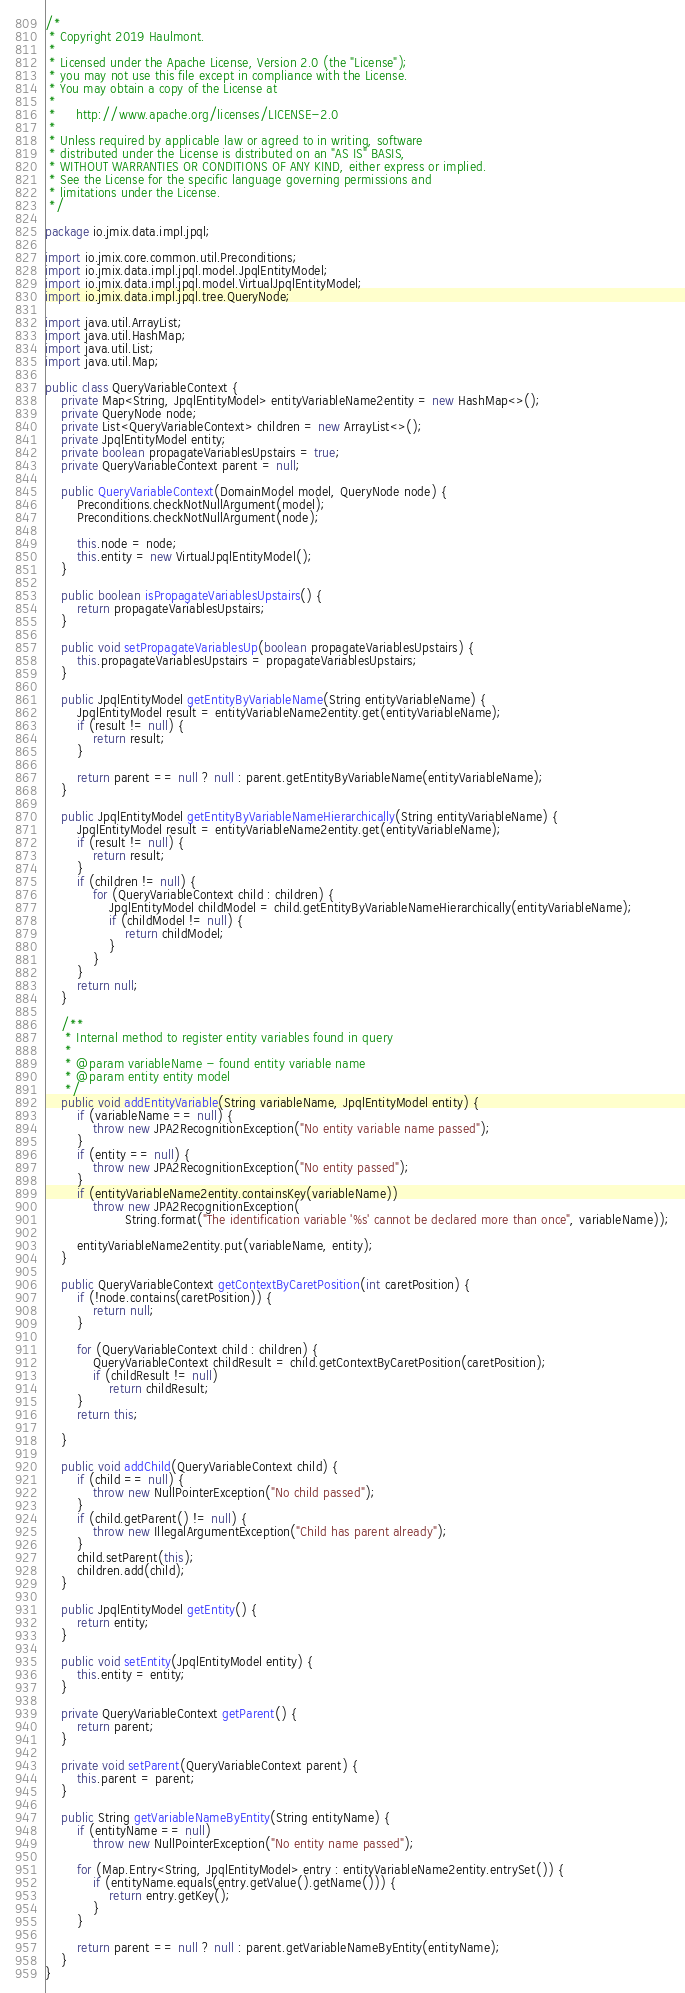Convert code to text. <code><loc_0><loc_0><loc_500><loc_500><_Java_>/*
 * Copyright 2019 Haulmont.
 *
 * Licensed under the Apache License, Version 2.0 (the "License");
 * you may not use this file except in compliance with the License.
 * You may obtain a copy of the License at
 *
 *     http://www.apache.org/licenses/LICENSE-2.0
 *
 * Unless required by applicable law or agreed to in writing, software
 * distributed under the License is distributed on an "AS IS" BASIS,
 * WITHOUT WARRANTIES OR CONDITIONS OF ANY KIND, either express or implied.
 * See the License for the specific language governing permissions and
 * limitations under the License.
 */

package io.jmix.data.impl.jpql;

import io.jmix.core.common.util.Preconditions;
import io.jmix.data.impl.jpql.model.JpqlEntityModel;
import io.jmix.data.impl.jpql.model.VirtualJpqlEntityModel;
import io.jmix.data.impl.jpql.tree.QueryNode;

import java.util.ArrayList;
import java.util.HashMap;
import java.util.List;
import java.util.Map;

public class QueryVariableContext {
    private Map<String, JpqlEntityModel> entityVariableName2entity = new HashMap<>();
    private QueryNode node;
    private List<QueryVariableContext> children = new ArrayList<>();
    private JpqlEntityModel entity;
    private boolean propagateVariablesUpstairs = true;
    private QueryVariableContext parent = null;

    public QueryVariableContext(DomainModel model, QueryNode node) {
        Preconditions.checkNotNullArgument(model);
        Preconditions.checkNotNullArgument(node);

        this.node = node;
        this.entity = new VirtualJpqlEntityModel();
    }

    public boolean isPropagateVariablesUpstairs() {
        return propagateVariablesUpstairs;
    }

    public void setPropagateVariablesUp(boolean propagateVariablesUpstairs) {
        this.propagateVariablesUpstairs = propagateVariablesUpstairs;
    }

    public JpqlEntityModel getEntityByVariableName(String entityVariableName) {
        JpqlEntityModel result = entityVariableName2entity.get(entityVariableName);
        if (result != null) {
            return result;
        }

        return parent == null ? null : parent.getEntityByVariableName(entityVariableName);
    }

    public JpqlEntityModel getEntityByVariableNameHierarchically(String entityVariableName) {
        JpqlEntityModel result = entityVariableName2entity.get(entityVariableName);
        if (result != null) {
            return result;
        }
        if (children != null) {
            for (QueryVariableContext child : children) {
                JpqlEntityModel childModel = child.getEntityByVariableNameHierarchically(entityVariableName);
                if (childModel != null) {
                    return childModel;
                }
            }
        }
        return null;
    }

    /**
     * Internal method to register entity variables found in query
     *
     * @param variableName - found entity variable name
     * @param entity entity model
     */
    public void addEntityVariable(String variableName, JpqlEntityModel entity) {
        if (variableName == null) {
            throw new JPA2RecognitionException("No entity variable name passed");
        }
        if (entity == null) {
            throw new JPA2RecognitionException("No entity passed");
        }
        if (entityVariableName2entity.containsKey(variableName))
            throw new JPA2RecognitionException(
                    String.format("The identification variable '%s' cannot be declared more than once", variableName));
        
        entityVariableName2entity.put(variableName, entity);
    }

    public QueryVariableContext getContextByCaretPosition(int caretPosition) {
        if (!node.contains(caretPosition)) {
            return null;
        }

        for (QueryVariableContext child : children) {
            QueryVariableContext childResult = child.getContextByCaretPosition(caretPosition);
            if (childResult != null)
                return childResult;
        }
        return this;

    }

    public void addChild(QueryVariableContext child) {
        if (child == null) {
            throw new NullPointerException("No child passed");
        }
        if (child.getParent() != null) {
            throw new IllegalArgumentException("Child has parent already");
        }
        child.setParent(this);
        children.add(child);
    }

    public JpqlEntityModel getEntity() {
        return entity;
    }

    public void setEntity(JpqlEntityModel entity) {
        this.entity = entity;
    }

    private QueryVariableContext getParent() {
        return parent;
    }

    private void setParent(QueryVariableContext parent) {
        this.parent = parent;
    }

    public String getVariableNameByEntity(String entityName) {
        if (entityName == null)
            throw new NullPointerException("No entity name passed");

        for (Map.Entry<String, JpqlEntityModel> entry : entityVariableName2entity.entrySet()) {
            if (entityName.equals(entry.getValue().getName())) {
                return entry.getKey();
            }
        }

        return parent == null ? null : parent.getVariableNameByEntity(entityName);
    }
}</code> 